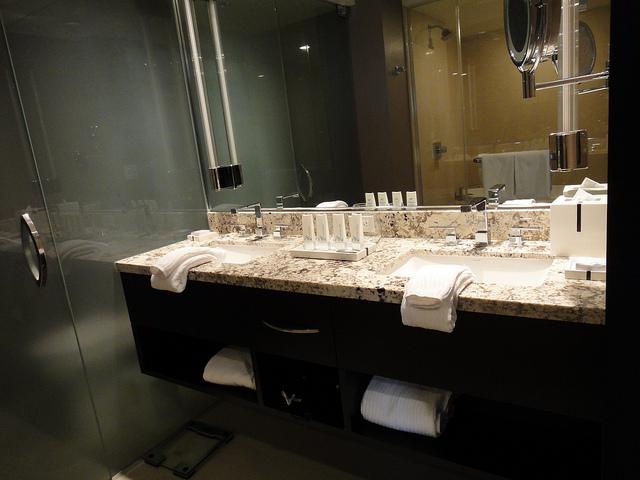How many towels are on the counter?
Answer briefly. 4. Is this a bedroom?
Write a very short answer. No. Is the water running?
Quick response, please. No. 